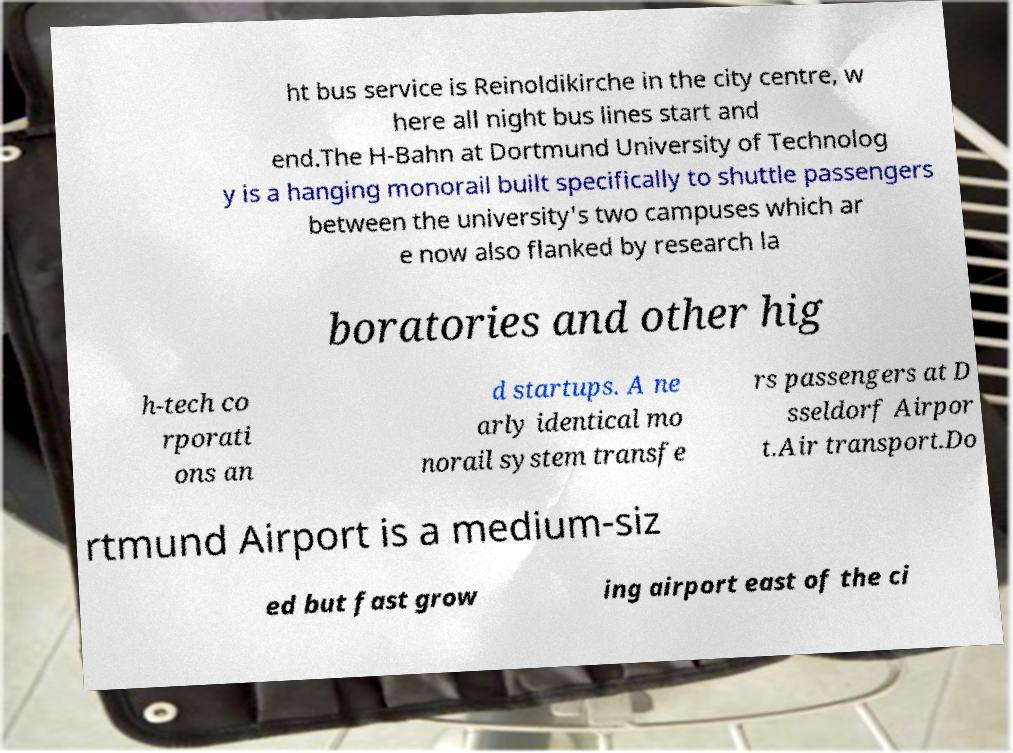Please identify and transcribe the text found in this image. ht bus service is Reinoldikirche in the city centre, w here all night bus lines start and end.The H-Bahn at Dortmund University of Technolog y is a hanging monorail built specifically to shuttle passengers between the university's two campuses which ar e now also flanked by research la boratories and other hig h-tech co rporati ons an d startups. A ne arly identical mo norail system transfe rs passengers at D sseldorf Airpor t.Air transport.Do rtmund Airport is a medium-siz ed but fast grow ing airport east of the ci 